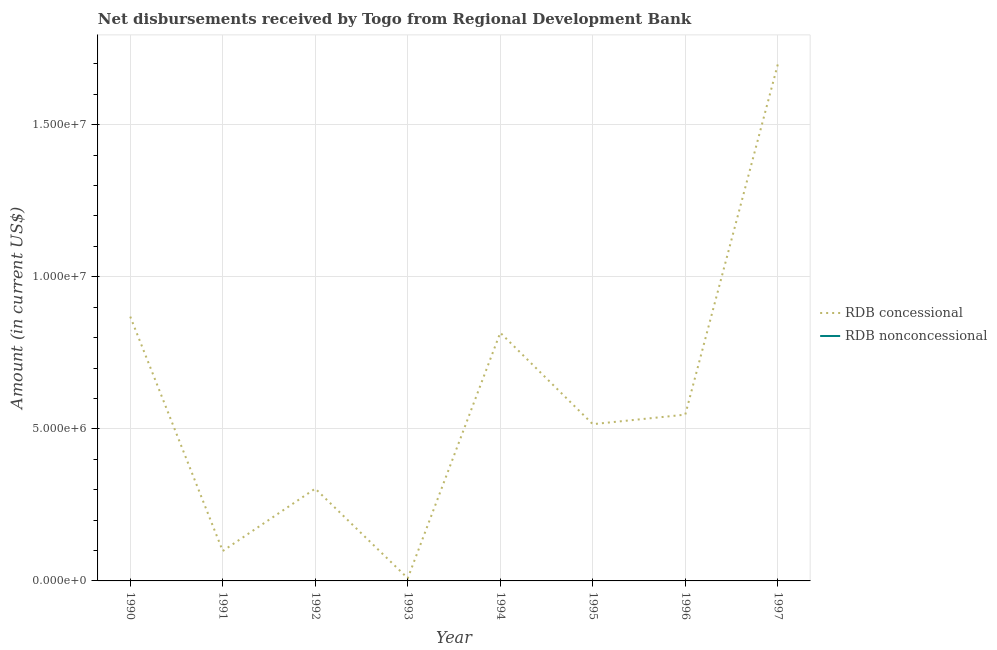Does the line corresponding to net concessional disbursements from rdb intersect with the line corresponding to net non concessional disbursements from rdb?
Keep it short and to the point. No. Is the number of lines equal to the number of legend labels?
Ensure brevity in your answer.  No. Across all years, what is the maximum net concessional disbursements from rdb?
Offer a terse response. 1.70e+07. Across all years, what is the minimum net concessional disbursements from rdb?
Ensure brevity in your answer.  8.80e+04. What is the total net concessional disbursements from rdb in the graph?
Give a very brief answer. 4.86e+07. What is the difference between the net concessional disbursements from rdb in 1996 and that in 1997?
Provide a short and direct response. -1.15e+07. What is the difference between the net concessional disbursements from rdb in 1991 and the net non concessional disbursements from rdb in 1997?
Provide a short and direct response. 9.84e+05. What is the ratio of the net concessional disbursements from rdb in 1990 to that in 1994?
Keep it short and to the point. 1.06. Is the net concessional disbursements from rdb in 1991 less than that in 1997?
Offer a very short reply. Yes. What is the difference between the highest and the second highest net concessional disbursements from rdb?
Make the answer very short. 8.29e+06. What is the difference between the highest and the lowest net concessional disbursements from rdb?
Your response must be concise. 1.69e+07. Is the sum of the net concessional disbursements from rdb in 1990 and 1992 greater than the maximum net non concessional disbursements from rdb across all years?
Your answer should be very brief. Yes. Is the net non concessional disbursements from rdb strictly greater than the net concessional disbursements from rdb over the years?
Your answer should be compact. No. How many lines are there?
Your answer should be very brief. 1. Are the values on the major ticks of Y-axis written in scientific E-notation?
Provide a short and direct response. Yes. Does the graph contain any zero values?
Your answer should be compact. Yes. What is the title of the graph?
Keep it short and to the point. Net disbursements received by Togo from Regional Development Bank. Does "Stunting" appear as one of the legend labels in the graph?
Make the answer very short. No. What is the label or title of the X-axis?
Provide a short and direct response. Year. What is the label or title of the Y-axis?
Provide a short and direct response. Amount (in current US$). What is the Amount (in current US$) of RDB concessional in 1990?
Provide a short and direct response. 8.69e+06. What is the Amount (in current US$) of RDB concessional in 1991?
Provide a succinct answer. 9.84e+05. What is the Amount (in current US$) of RDB concessional in 1992?
Provide a short and direct response. 3.04e+06. What is the Amount (in current US$) of RDB concessional in 1993?
Your answer should be very brief. 8.80e+04. What is the Amount (in current US$) in RDB concessional in 1994?
Provide a short and direct response. 8.16e+06. What is the Amount (in current US$) of RDB concessional in 1995?
Your answer should be compact. 5.15e+06. What is the Amount (in current US$) in RDB nonconcessional in 1995?
Ensure brevity in your answer.  0. What is the Amount (in current US$) of RDB concessional in 1996?
Keep it short and to the point. 5.47e+06. What is the Amount (in current US$) of RDB nonconcessional in 1996?
Provide a succinct answer. 0. What is the Amount (in current US$) of RDB concessional in 1997?
Ensure brevity in your answer.  1.70e+07. What is the Amount (in current US$) of RDB nonconcessional in 1997?
Offer a very short reply. 0. Across all years, what is the maximum Amount (in current US$) in RDB concessional?
Keep it short and to the point. 1.70e+07. Across all years, what is the minimum Amount (in current US$) in RDB concessional?
Make the answer very short. 8.80e+04. What is the total Amount (in current US$) of RDB concessional in the graph?
Give a very brief answer. 4.86e+07. What is the difference between the Amount (in current US$) in RDB concessional in 1990 and that in 1991?
Your answer should be very brief. 7.71e+06. What is the difference between the Amount (in current US$) of RDB concessional in 1990 and that in 1992?
Your response must be concise. 5.66e+06. What is the difference between the Amount (in current US$) in RDB concessional in 1990 and that in 1993?
Offer a terse response. 8.60e+06. What is the difference between the Amount (in current US$) in RDB concessional in 1990 and that in 1994?
Offer a very short reply. 5.30e+05. What is the difference between the Amount (in current US$) in RDB concessional in 1990 and that in 1995?
Offer a very short reply. 3.54e+06. What is the difference between the Amount (in current US$) in RDB concessional in 1990 and that in 1996?
Offer a terse response. 3.22e+06. What is the difference between the Amount (in current US$) of RDB concessional in 1990 and that in 1997?
Keep it short and to the point. -8.29e+06. What is the difference between the Amount (in current US$) of RDB concessional in 1991 and that in 1992?
Provide a succinct answer. -2.05e+06. What is the difference between the Amount (in current US$) in RDB concessional in 1991 and that in 1993?
Provide a succinct answer. 8.96e+05. What is the difference between the Amount (in current US$) in RDB concessional in 1991 and that in 1994?
Provide a succinct answer. -7.18e+06. What is the difference between the Amount (in current US$) of RDB concessional in 1991 and that in 1995?
Keep it short and to the point. -4.17e+06. What is the difference between the Amount (in current US$) in RDB concessional in 1991 and that in 1996?
Offer a very short reply. -4.48e+06. What is the difference between the Amount (in current US$) in RDB concessional in 1991 and that in 1997?
Give a very brief answer. -1.60e+07. What is the difference between the Amount (in current US$) in RDB concessional in 1992 and that in 1993?
Ensure brevity in your answer.  2.95e+06. What is the difference between the Amount (in current US$) of RDB concessional in 1992 and that in 1994?
Make the answer very short. -5.13e+06. What is the difference between the Amount (in current US$) in RDB concessional in 1992 and that in 1995?
Provide a succinct answer. -2.12e+06. What is the difference between the Amount (in current US$) in RDB concessional in 1992 and that in 1996?
Make the answer very short. -2.43e+06. What is the difference between the Amount (in current US$) in RDB concessional in 1992 and that in 1997?
Provide a succinct answer. -1.39e+07. What is the difference between the Amount (in current US$) of RDB concessional in 1993 and that in 1994?
Give a very brief answer. -8.07e+06. What is the difference between the Amount (in current US$) in RDB concessional in 1993 and that in 1995?
Provide a short and direct response. -5.07e+06. What is the difference between the Amount (in current US$) of RDB concessional in 1993 and that in 1996?
Give a very brief answer. -5.38e+06. What is the difference between the Amount (in current US$) of RDB concessional in 1993 and that in 1997?
Keep it short and to the point. -1.69e+07. What is the difference between the Amount (in current US$) in RDB concessional in 1994 and that in 1995?
Your answer should be compact. 3.01e+06. What is the difference between the Amount (in current US$) of RDB concessional in 1994 and that in 1996?
Keep it short and to the point. 2.69e+06. What is the difference between the Amount (in current US$) in RDB concessional in 1994 and that in 1997?
Offer a terse response. -8.82e+06. What is the difference between the Amount (in current US$) in RDB concessional in 1995 and that in 1996?
Give a very brief answer. -3.13e+05. What is the difference between the Amount (in current US$) of RDB concessional in 1995 and that in 1997?
Offer a terse response. -1.18e+07. What is the difference between the Amount (in current US$) of RDB concessional in 1996 and that in 1997?
Make the answer very short. -1.15e+07. What is the average Amount (in current US$) in RDB concessional per year?
Offer a very short reply. 6.07e+06. What is the average Amount (in current US$) in RDB nonconcessional per year?
Offer a terse response. 0. What is the ratio of the Amount (in current US$) of RDB concessional in 1990 to that in 1991?
Your response must be concise. 8.83. What is the ratio of the Amount (in current US$) in RDB concessional in 1990 to that in 1992?
Keep it short and to the point. 2.86. What is the ratio of the Amount (in current US$) in RDB concessional in 1990 to that in 1993?
Give a very brief answer. 98.76. What is the ratio of the Amount (in current US$) in RDB concessional in 1990 to that in 1994?
Your answer should be compact. 1.06. What is the ratio of the Amount (in current US$) in RDB concessional in 1990 to that in 1995?
Your response must be concise. 1.69. What is the ratio of the Amount (in current US$) of RDB concessional in 1990 to that in 1996?
Offer a terse response. 1.59. What is the ratio of the Amount (in current US$) of RDB concessional in 1990 to that in 1997?
Offer a very short reply. 0.51. What is the ratio of the Amount (in current US$) in RDB concessional in 1991 to that in 1992?
Offer a very short reply. 0.32. What is the ratio of the Amount (in current US$) in RDB concessional in 1991 to that in 1993?
Ensure brevity in your answer.  11.18. What is the ratio of the Amount (in current US$) of RDB concessional in 1991 to that in 1994?
Keep it short and to the point. 0.12. What is the ratio of the Amount (in current US$) in RDB concessional in 1991 to that in 1995?
Your response must be concise. 0.19. What is the ratio of the Amount (in current US$) of RDB concessional in 1991 to that in 1996?
Your answer should be very brief. 0.18. What is the ratio of the Amount (in current US$) in RDB concessional in 1991 to that in 1997?
Your response must be concise. 0.06. What is the ratio of the Amount (in current US$) of RDB concessional in 1992 to that in 1993?
Keep it short and to the point. 34.49. What is the ratio of the Amount (in current US$) in RDB concessional in 1992 to that in 1994?
Your answer should be compact. 0.37. What is the ratio of the Amount (in current US$) in RDB concessional in 1992 to that in 1995?
Provide a short and direct response. 0.59. What is the ratio of the Amount (in current US$) in RDB concessional in 1992 to that in 1996?
Offer a very short reply. 0.56. What is the ratio of the Amount (in current US$) of RDB concessional in 1992 to that in 1997?
Give a very brief answer. 0.18. What is the ratio of the Amount (in current US$) in RDB concessional in 1993 to that in 1994?
Provide a short and direct response. 0.01. What is the ratio of the Amount (in current US$) in RDB concessional in 1993 to that in 1995?
Provide a short and direct response. 0.02. What is the ratio of the Amount (in current US$) in RDB concessional in 1993 to that in 1996?
Your response must be concise. 0.02. What is the ratio of the Amount (in current US$) in RDB concessional in 1993 to that in 1997?
Make the answer very short. 0.01. What is the ratio of the Amount (in current US$) of RDB concessional in 1994 to that in 1995?
Your response must be concise. 1.58. What is the ratio of the Amount (in current US$) in RDB concessional in 1994 to that in 1996?
Your answer should be very brief. 1.49. What is the ratio of the Amount (in current US$) of RDB concessional in 1994 to that in 1997?
Your answer should be very brief. 0.48. What is the ratio of the Amount (in current US$) in RDB concessional in 1995 to that in 1996?
Provide a succinct answer. 0.94. What is the ratio of the Amount (in current US$) of RDB concessional in 1995 to that in 1997?
Ensure brevity in your answer.  0.3. What is the ratio of the Amount (in current US$) of RDB concessional in 1996 to that in 1997?
Make the answer very short. 0.32. What is the difference between the highest and the second highest Amount (in current US$) of RDB concessional?
Offer a very short reply. 8.29e+06. What is the difference between the highest and the lowest Amount (in current US$) of RDB concessional?
Your response must be concise. 1.69e+07. 